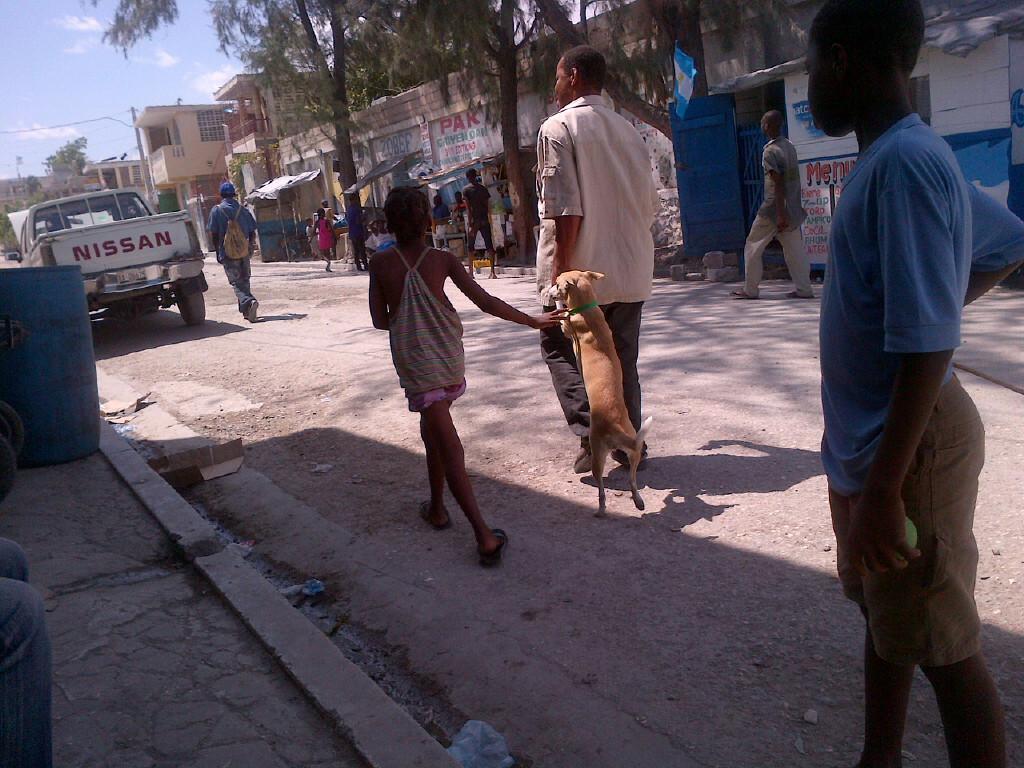In one or two sentences, can you explain what this image depicts? I can see in this image there are group of people who are walking on the road along with a dog. I can also see there are few trees, buildings and a vehicle. 